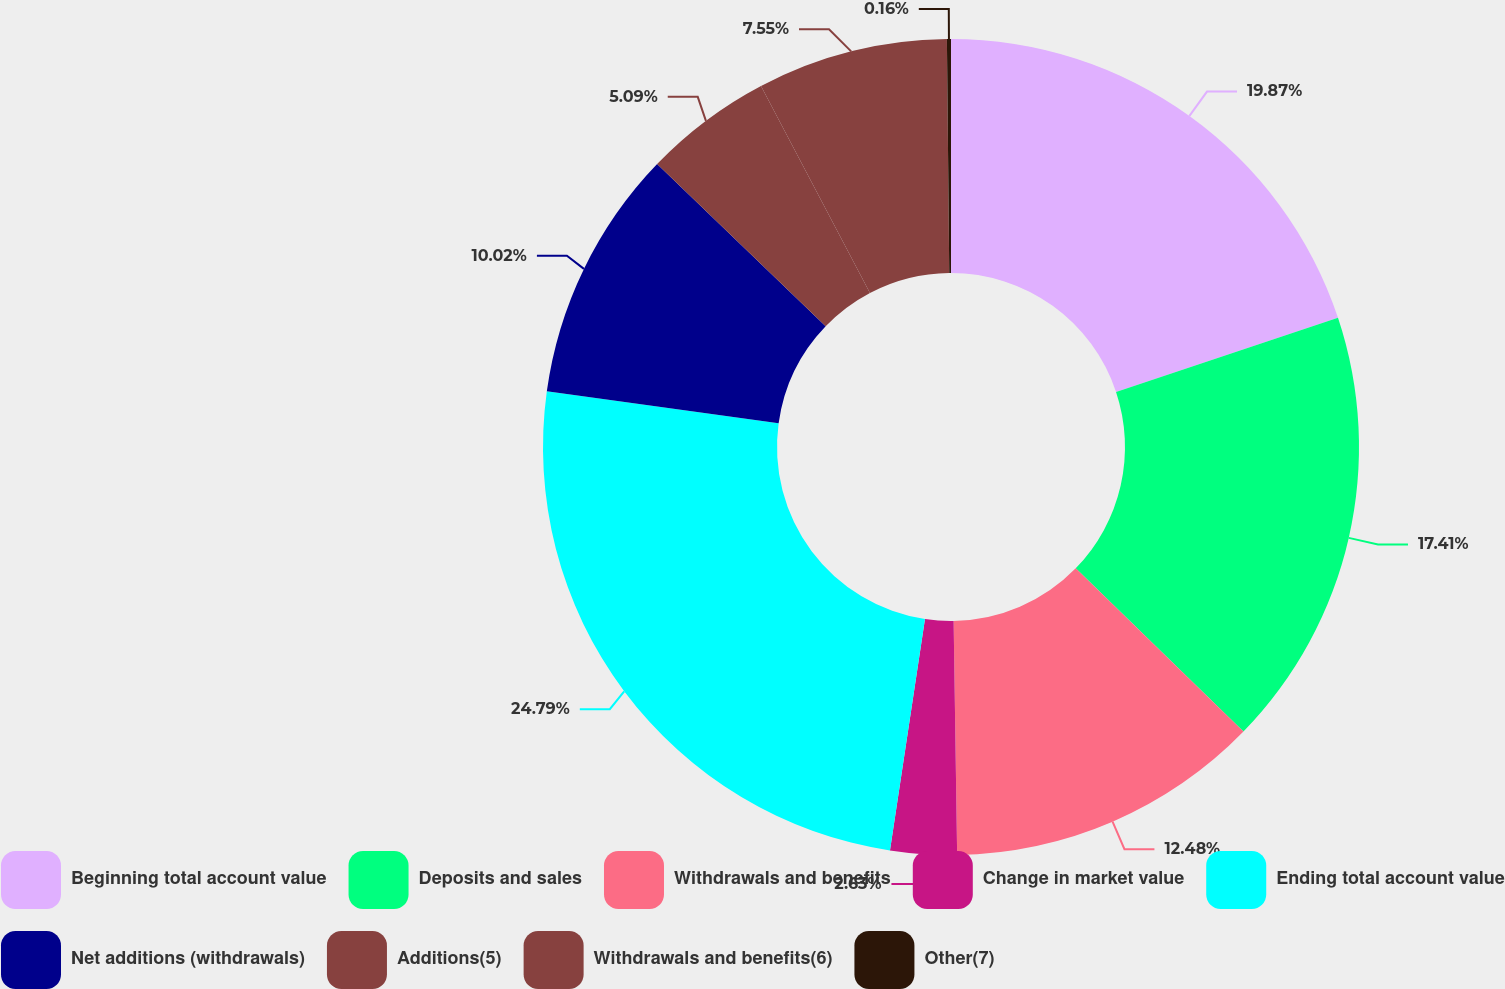Convert chart to OTSL. <chart><loc_0><loc_0><loc_500><loc_500><pie_chart><fcel>Beginning total account value<fcel>Deposits and sales<fcel>Withdrawals and benefits<fcel>Change in market value<fcel>Ending total account value<fcel>Net additions (withdrawals)<fcel>Additions(5)<fcel>Withdrawals and benefits(6)<fcel>Other(7)<nl><fcel>19.87%<fcel>17.41%<fcel>12.48%<fcel>2.63%<fcel>24.79%<fcel>10.02%<fcel>5.09%<fcel>7.55%<fcel>0.16%<nl></chart> 